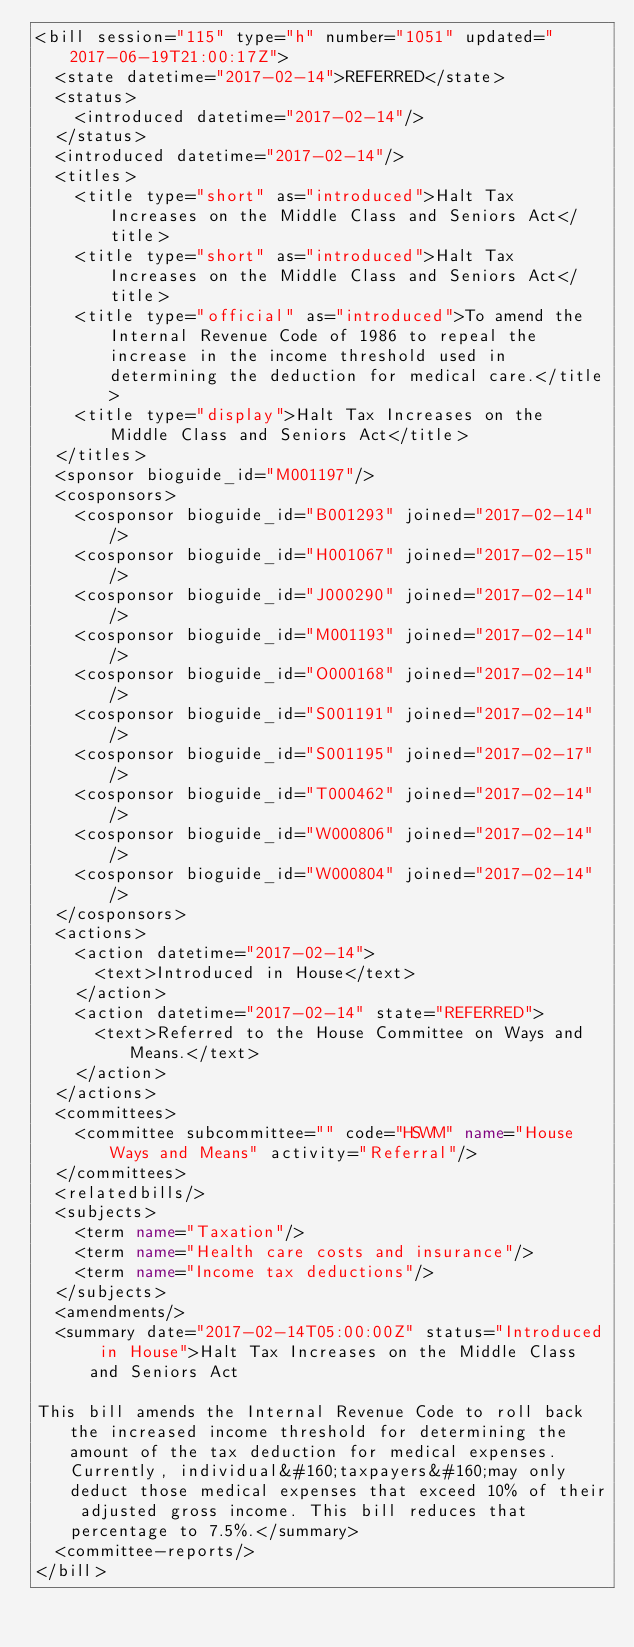Convert code to text. <code><loc_0><loc_0><loc_500><loc_500><_XML_><bill session="115" type="h" number="1051" updated="2017-06-19T21:00:17Z">
  <state datetime="2017-02-14">REFERRED</state>
  <status>
    <introduced datetime="2017-02-14"/>
  </status>
  <introduced datetime="2017-02-14"/>
  <titles>
    <title type="short" as="introduced">Halt Tax Increases on the Middle Class and Seniors Act</title>
    <title type="short" as="introduced">Halt Tax Increases on the Middle Class and Seniors Act</title>
    <title type="official" as="introduced">To amend the Internal Revenue Code of 1986 to repeal the increase in the income threshold used in determining the deduction for medical care.</title>
    <title type="display">Halt Tax Increases on the Middle Class and Seniors Act</title>
  </titles>
  <sponsor bioguide_id="M001197"/>
  <cosponsors>
    <cosponsor bioguide_id="B001293" joined="2017-02-14"/>
    <cosponsor bioguide_id="H001067" joined="2017-02-15"/>
    <cosponsor bioguide_id="J000290" joined="2017-02-14"/>
    <cosponsor bioguide_id="M001193" joined="2017-02-14"/>
    <cosponsor bioguide_id="O000168" joined="2017-02-14"/>
    <cosponsor bioguide_id="S001191" joined="2017-02-14"/>
    <cosponsor bioguide_id="S001195" joined="2017-02-17"/>
    <cosponsor bioguide_id="T000462" joined="2017-02-14"/>
    <cosponsor bioguide_id="W000806" joined="2017-02-14"/>
    <cosponsor bioguide_id="W000804" joined="2017-02-14"/>
  </cosponsors>
  <actions>
    <action datetime="2017-02-14">
      <text>Introduced in House</text>
    </action>
    <action datetime="2017-02-14" state="REFERRED">
      <text>Referred to the House Committee on Ways and Means.</text>
    </action>
  </actions>
  <committees>
    <committee subcommittee="" code="HSWM" name="House Ways and Means" activity="Referral"/>
  </committees>
  <relatedbills/>
  <subjects>
    <term name="Taxation"/>
    <term name="Health care costs and insurance"/>
    <term name="Income tax deductions"/>
  </subjects>
  <amendments/>
  <summary date="2017-02-14T05:00:00Z" status="Introduced in House">Halt Tax Increases on the Middle Class and Seniors Act

This bill amends the Internal Revenue Code to roll back the increased income threshold for determining the amount of the tax deduction for medical expenses. Currently, individual&#160;taxpayers&#160;may only deduct those medical expenses that exceed 10% of their adjusted gross income. This bill reduces that percentage to 7.5%.</summary>
  <committee-reports/>
</bill>
</code> 